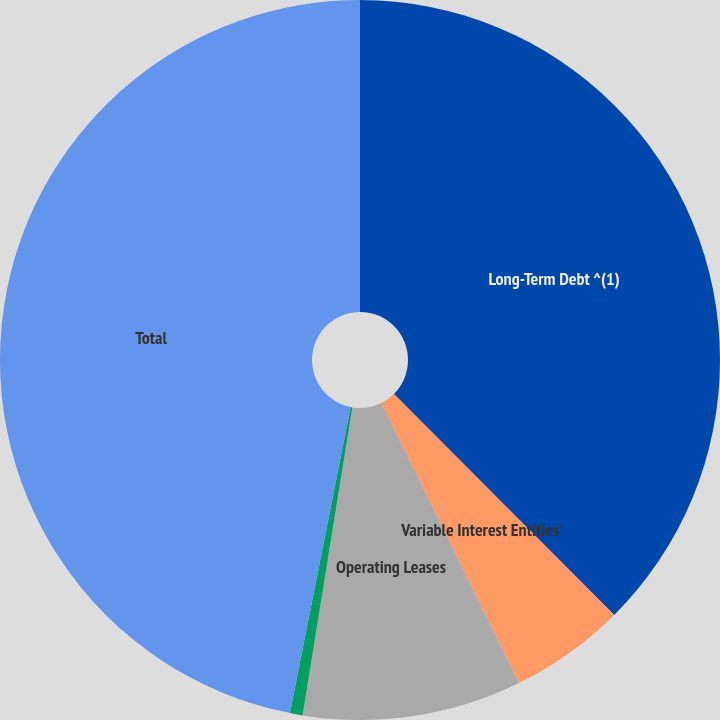Convert chart. <chart><loc_0><loc_0><loc_500><loc_500><pie_chart><fcel>Long-Term Debt ^(1)<fcel>Variable Interest Entities'<fcel>Operating Leases<fcel>James Stadium<fcel>Total<nl><fcel>37.52%<fcel>5.2%<fcel>9.83%<fcel>0.57%<fcel>46.88%<nl></chart> 